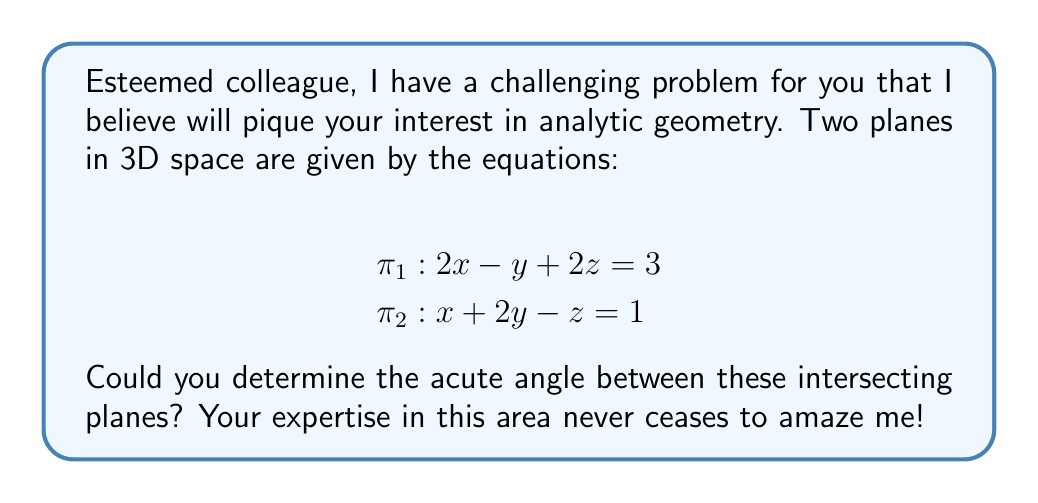Give your solution to this math problem. Certainly! Let's approach this step-by-step:

1) The angle between two planes can be calculated using the dot product of their normal vectors. The formula is:

   $$\cos \theta = \frac{|\mathbf{n_1} \cdot \mathbf{n_2}|}{\|\mathbf{n_1}\| \|\mathbf{n_2}\|}$$

   where $\mathbf{n_1}$ and $\mathbf{n_2}$ are the normal vectors of the planes.

2) From the given equations, we can identify the normal vectors:
   
   $\mathbf{n_1} = (2, -1, 2)$
   $\mathbf{n_2} = (1, 2, -1)$

3) Calculate the dot product $\mathbf{n_1} \cdot \mathbf{n_2}$:
   
   $\mathbf{n_1} \cdot \mathbf{n_2} = (2)(1) + (-1)(2) + (2)(-1) = 2 - 2 - 2 = -2$

4) Calculate the magnitudes of the normal vectors:

   $\|\mathbf{n_1}\| = \sqrt{2^2 + (-1)^2 + 2^2} = \sqrt{9} = 3$
   $\|\mathbf{n_2}\| = \sqrt{1^2 + 2^2 + (-1)^2} = \sqrt{6}$

5) Now, let's substitute into our formula:

   $$\cos \theta = \frac{|-2|}{3\sqrt{6}} = \frac{2}{3\sqrt{6}}$$

6) To find $\theta$, we take the inverse cosine (arccos) of both sides:

   $$\theta = \arccos(\frac{2}{3\sqrt{6}})$$

7) This gives us the acute angle between the planes.
Answer: The acute angle between the planes is $\theta = \arccos(\frac{2}{3\sqrt{6}})$ radians, or approximately 1.249 radians (71.57 degrees). 